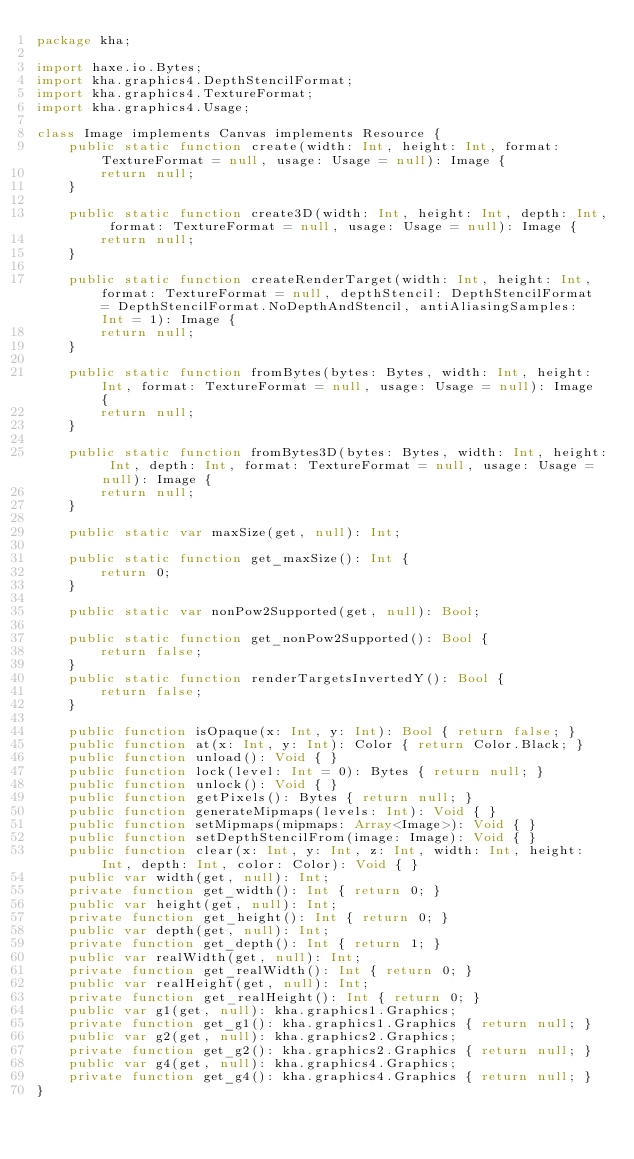Convert code to text. <code><loc_0><loc_0><loc_500><loc_500><_Haxe_>package kha;

import haxe.io.Bytes;
import kha.graphics4.DepthStencilFormat;
import kha.graphics4.TextureFormat;
import kha.graphics4.Usage;

class Image implements Canvas implements Resource {
	public static function create(width: Int, height: Int, format: TextureFormat = null, usage: Usage = null): Image {
		return null;
	}

	public static function create3D(width: Int, height: Int, depth: Int, format: TextureFormat = null, usage: Usage = null): Image {
		return null;
	}

	public static function createRenderTarget(width: Int, height: Int, format: TextureFormat = null, depthStencil: DepthStencilFormat = DepthStencilFormat.NoDepthAndStencil, antiAliasingSamples: Int = 1): Image {
		return null;
	}
	
	public static function fromBytes(bytes: Bytes, width: Int, height: Int, format: TextureFormat = null, usage: Usage = null): Image {
		return null;
	}

	public static function fromBytes3D(bytes: Bytes, width: Int, height: Int, depth: Int, format: TextureFormat = null, usage: Usage = null): Image {
		return null;
	}

	public static var maxSize(get, null): Int;

	public static function get_maxSize(): Int {
		return 0;
	}

	public static var nonPow2Supported(get, null): Bool;

	public static function get_nonPow2Supported(): Bool {
		return false;
	}
	public static function renderTargetsInvertedY(): Bool {
		return false;
	}

	public function isOpaque(x: Int, y: Int): Bool { return false; }
	public function at(x: Int, y: Int): Color { return Color.Black; }
	public function unload(): Void { }
	public function lock(level: Int = 0): Bytes { return null; }
	public function unlock(): Void { }
	public function getPixels(): Bytes { return null; }
	public function generateMipmaps(levels: Int): Void { }
	public function setMipmaps(mipmaps: Array<Image>): Void { }
	public function setDepthStencilFrom(image: Image): Void { }
	public function clear(x: Int, y: Int, z: Int, width: Int, height: Int, depth: Int, color: Color): Void { }
	public var width(get, null): Int;
	private function get_width(): Int { return 0; }
	public var height(get, null): Int;
	private function get_height(): Int { return 0; }
	public var depth(get, null): Int;
	private function get_depth(): Int { return 1; }
	public var realWidth(get, null): Int;
	private function get_realWidth(): Int { return 0; }
	public var realHeight(get, null): Int;
	private function get_realHeight(): Int { return 0; }
	public var g1(get, null): kha.graphics1.Graphics;
	private function get_g1(): kha.graphics1.Graphics { return null; }
	public var g2(get, null): kha.graphics2.Graphics;
	private function get_g2(): kha.graphics2.Graphics { return null; }
	public var g4(get, null): kha.graphics4.Graphics;
	private function get_g4(): kha.graphics4.Graphics { return null; }
}
</code> 